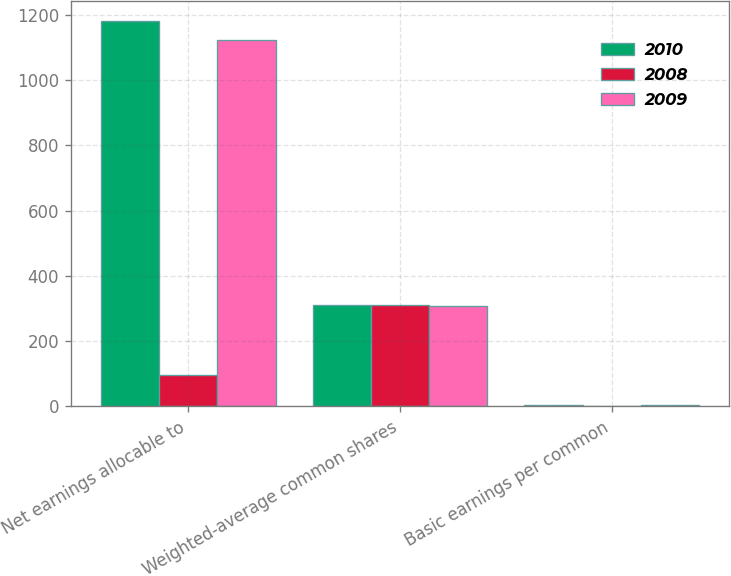<chart> <loc_0><loc_0><loc_500><loc_500><stacked_bar_chart><ecel><fcel>Net earnings allocable to<fcel>Weighted-average common shares<fcel>Basic earnings per common<nl><fcel>2010<fcel>1182<fcel>312<fcel>3.78<nl><fcel>2008<fcel>97<fcel>311<fcel>0.31<nl><fcel>2009<fcel>1123<fcel>309<fcel>3.64<nl></chart> 